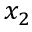Convert formula to latex. <formula><loc_0><loc_0><loc_500><loc_500>x _ { 2 }</formula> 